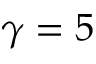Convert formula to latex. <formula><loc_0><loc_0><loc_500><loc_500>\gamma = 5</formula> 